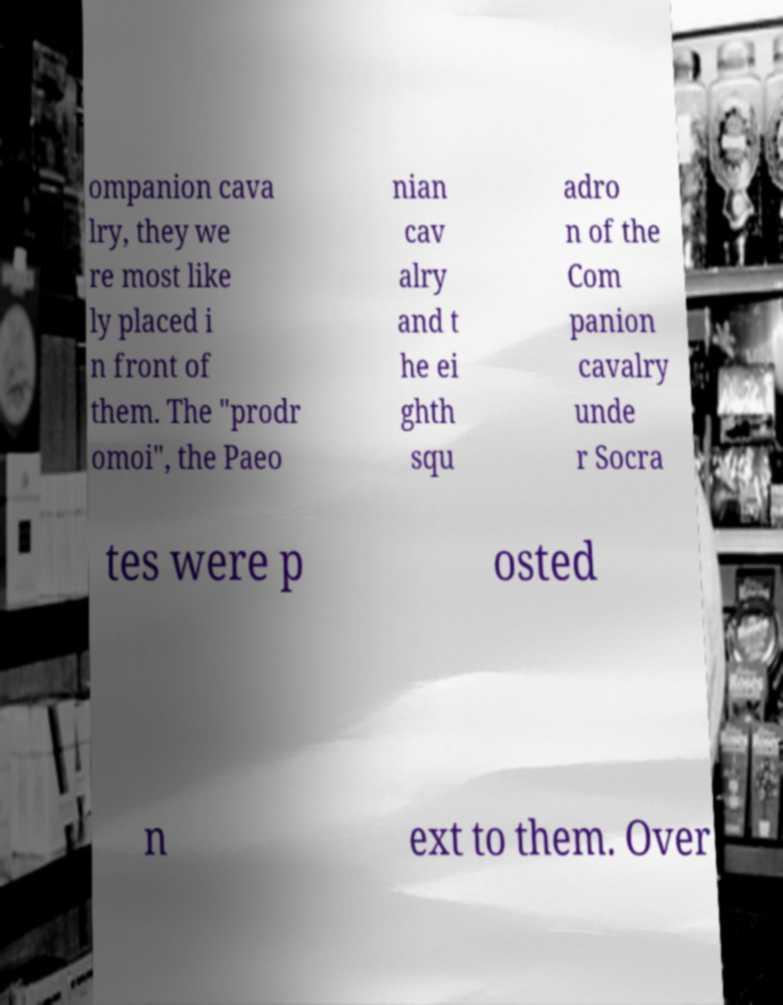What messages or text are displayed in this image? I need them in a readable, typed format. ompanion cava lry, they we re most like ly placed i n front of them. The "prodr omoi", the Paeo nian cav alry and t he ei ghth squ adro n of the Com panion cavalry unde r Socra tes were p osted n ext to them. Over 